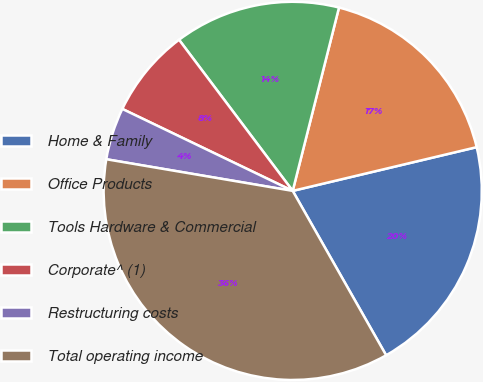Convert chart. <chart><loc_0><loc_0><loc_500><loc_500><pie_chart><fcel>Home & Family<fcel>Office Products<fcel>Tools Hardware & Commercial<fcel>Corporate^ (1)<fcel>Restructuring costs<fcel>Total operating income<nl><fcel>20.49%<fcel>17.35%<fcel>14.2%<fcel>7.6%<fcel>4.46%<fcel>35.9%<nl></chart> 